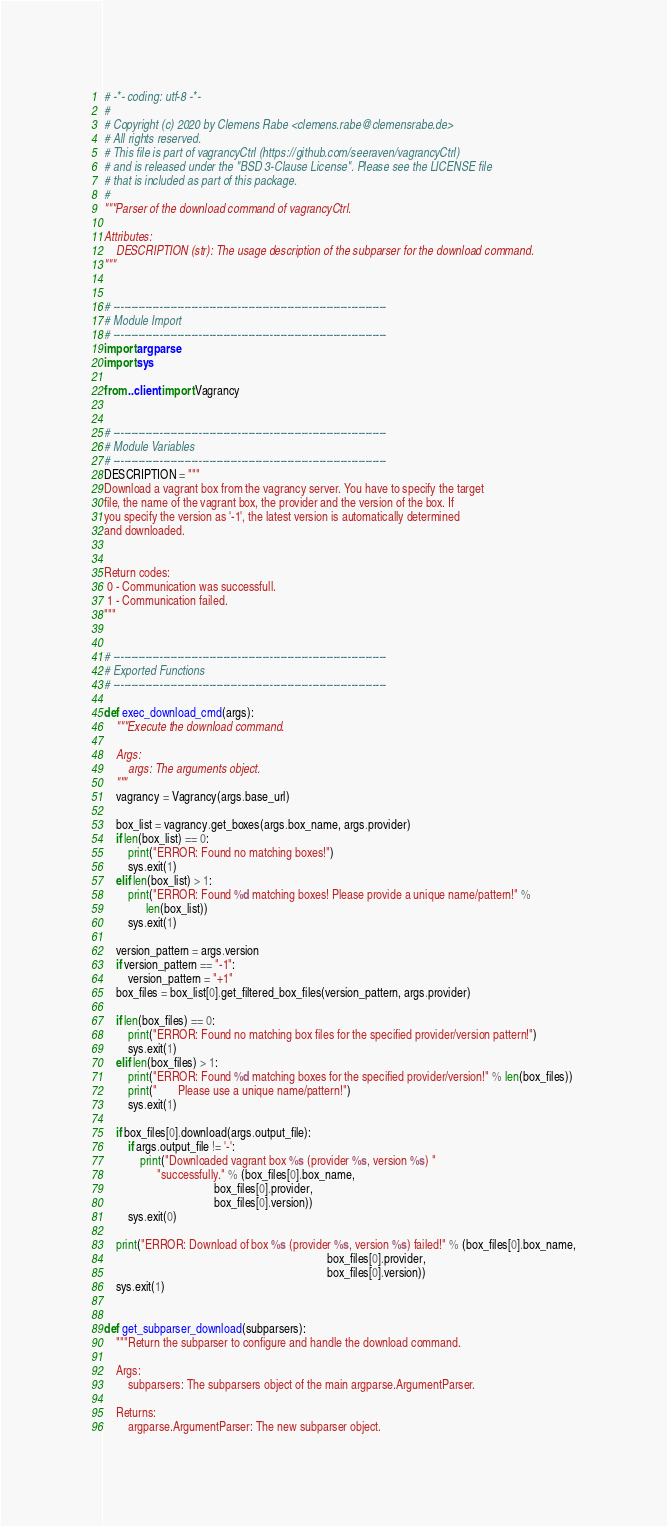<code> <loc_0><loc_0><loc_500><loc_500><_Python_># -*- coding: utf-8 -*-
#
# Copyright (c) 2020 by Clemens Rabe <clemens.rabe@clemensrabe.de>
# All rights reserved.
# This file is part of vagrancyCtrl (https://github.com/seeraven/vagrancyCtrl)
# and is released under the "BSD 3-Clause License". Please see the LICENSE file
# that is included as part of this package.
#
"""Parser of the download command of vagrancyCtrl.

Attributes:
    DESCRIPTION (str): The usage description of the subparser for the download command.
"""


# -----------------------------------------------------------------------------
# Module Import
# -----------------------------------------------------------------------------
import argparse
import sys

from ..client import Vagrancy


# -----------------------------------------------------------------------------
# Module Variables
# -----------------------------------------------------------------------------
DESCRIPTION = """
Download a vagrant box from the vagrancy server. You have to specify the target
file, the name of the vagrant box, the provider and the version of the box. If
you specify the version as '-1', the latest version is automatically determined
and downloaded.


Return codes:
 0 - Communication was successfull.
 1 - Communication failed.
"""


# -----------------------------------------------------------------------------
# Exported Functions
# -----------------------------------------------------------------------------

def exec_download_cmd(args):
    """Execute the download command.

    Args:
        args: The arguments object.
    """
    vagrancy = Vagrancy(args.base_url)

    box_list = vagrancy.get_boxes(args.box_name, args.provider)
    if len(box_list) == 0:
        print("ERROR: Found no matching boxes!")
        sys.exit(1)
    elif len(box_list) > 1:
        print("ERROR: Found %d matching boxes! Please provide a unique name/pattern!" %
              len(box_list))
        sys.exit(1)

    version_pattern = args.version
    if version_pattern == "-1":
        version_pattern = "+1"
    box_files = box_list[0].get_filtered_box_files(version_pattern, args.provider)

    if len(box_files) == 0:
        print("ERROR: Found no matching box files for the specified provider/version pattern!")
        sys.exit(1)
    elif len(box_files) > 1:
        print("ERROR: Found %d matching boxes for the specified provider/version!" % len(box_files))
        print("       Please use a unique name/pattern!")
        sys.exit(1)

    if box_files[0].download(args.output_file):
        if args.output_file != '-':
            print("Downloaded vagrant box %s (provider %s, version %s) "
                  "successfully." % (box_files[0].box_name,
                                     box_files[0].provider,
                                     box_files[0].version))
        sys.exit(0)

    print("ERROR: Download of box %s (provider %s, version %s) failed!" % (box_files[0].box_name,
                                                                           box_files[0].provider,
                                                                           box_files[0].version))
    sys.exit(1)


def get_subparser_download(subparsers):
    """Return the subparser to configure and handle the download command.

    Args:
        subparsers: The subparsers object of the main argparse.ArgumentParser.

    Returns:
        argparse.ArgumentParser: The new subparser object.</code> 